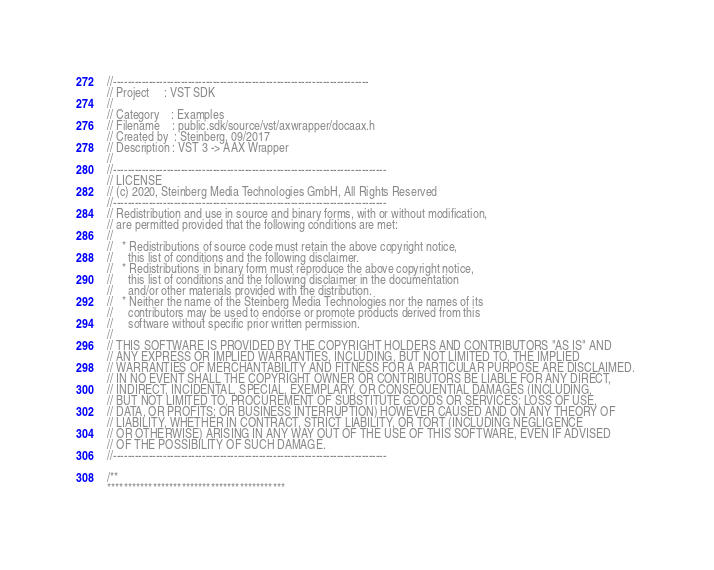Convert code to text. <code><loc_0><loc_0><loc_500><loc_500><_C_>//------------------------------------------------------------------------
// Project     : VST SDK
//
// Category    : Examples
// Filename    : public.sdk/source/vst/axwrapper/docaax.h
// Created by  : Steinberg, 09/2017
// Description : VST 3 -> AAX Wrapper
//
//-----------------------------------------------------------------------------
// LICENSE
// (c) 2020, Steinberg Media Technologies GmbH, All Rights Reserved
//-----------------------------------------------------------------------------
// Redistribution and use in source and binary forms, with or without modification,
// are permitted provided that the following conditions are met:
// 
//   * Redistributions of source code must retain the above copyright notice, 
//     this list of conditions and the following disclaimer.
//   * Redistributions in binary form must reproduce the above copyright notice,
//     this list of conditions and the following disclaimer in the documentation 
//     and/or other materials provided with the distribution.
//   * Neither the name of the Steinberg Media Technologies nor the names of its
//     contributors may be used to endorse or promote products derived from this 
//     software without specific prior written permission.
// 
// THIS SOFTWARE IS PROVIDED BY THE COPYRIGHT HOLDERS AND CONTRIBUTORS "AS IS" AND
// ANY EXPRESS OR IMPLIED WARRANTIES, INCLUDING, BUT NOT LIMITED TO, THE IMPLIED 
// WARRANTIES OF MERCHANTABILITY AND FITNESS FOR A PARTICULAR PURPOSE ARE DISCLAIMED. 
// IN NO EVENT SHALL THE COPYRIGHT OWNER OR CONTRIBUTORS BE LIABLE FOR ANY DIRECT, 
// INDIRECT, INCIDENTAL, SPECIAL, EXEMPLARY, OR CONSEQUENTIAL DAMAGES (INCLUDING, 
// BUT NOT LIMITED TO, PROCUREMENT OF SUBSTITUTE GOODS OR SERVICES; LOSS OF USE, 
// DATA, OR PROFITS; OR BUSINESS INTERRUPTION) HOWEVER CAUSED AND ON ANY THEORY OF 
// LIABILITY, WHETHER IN CONTRACT, STRICT LIABILITY, OR TORT (INCLUDING NEGLIGENCE 
// OR OTHERWISE) ARISING IN ANY WAY OUT OF THE USE OF THIS SOFTWARE, EVEN IF ADVISED
// OF THE POSSIBILITY OF SUCH DAMAGE.
//-----------------------------------------------------------------------------

/**
*******************************************</code> 